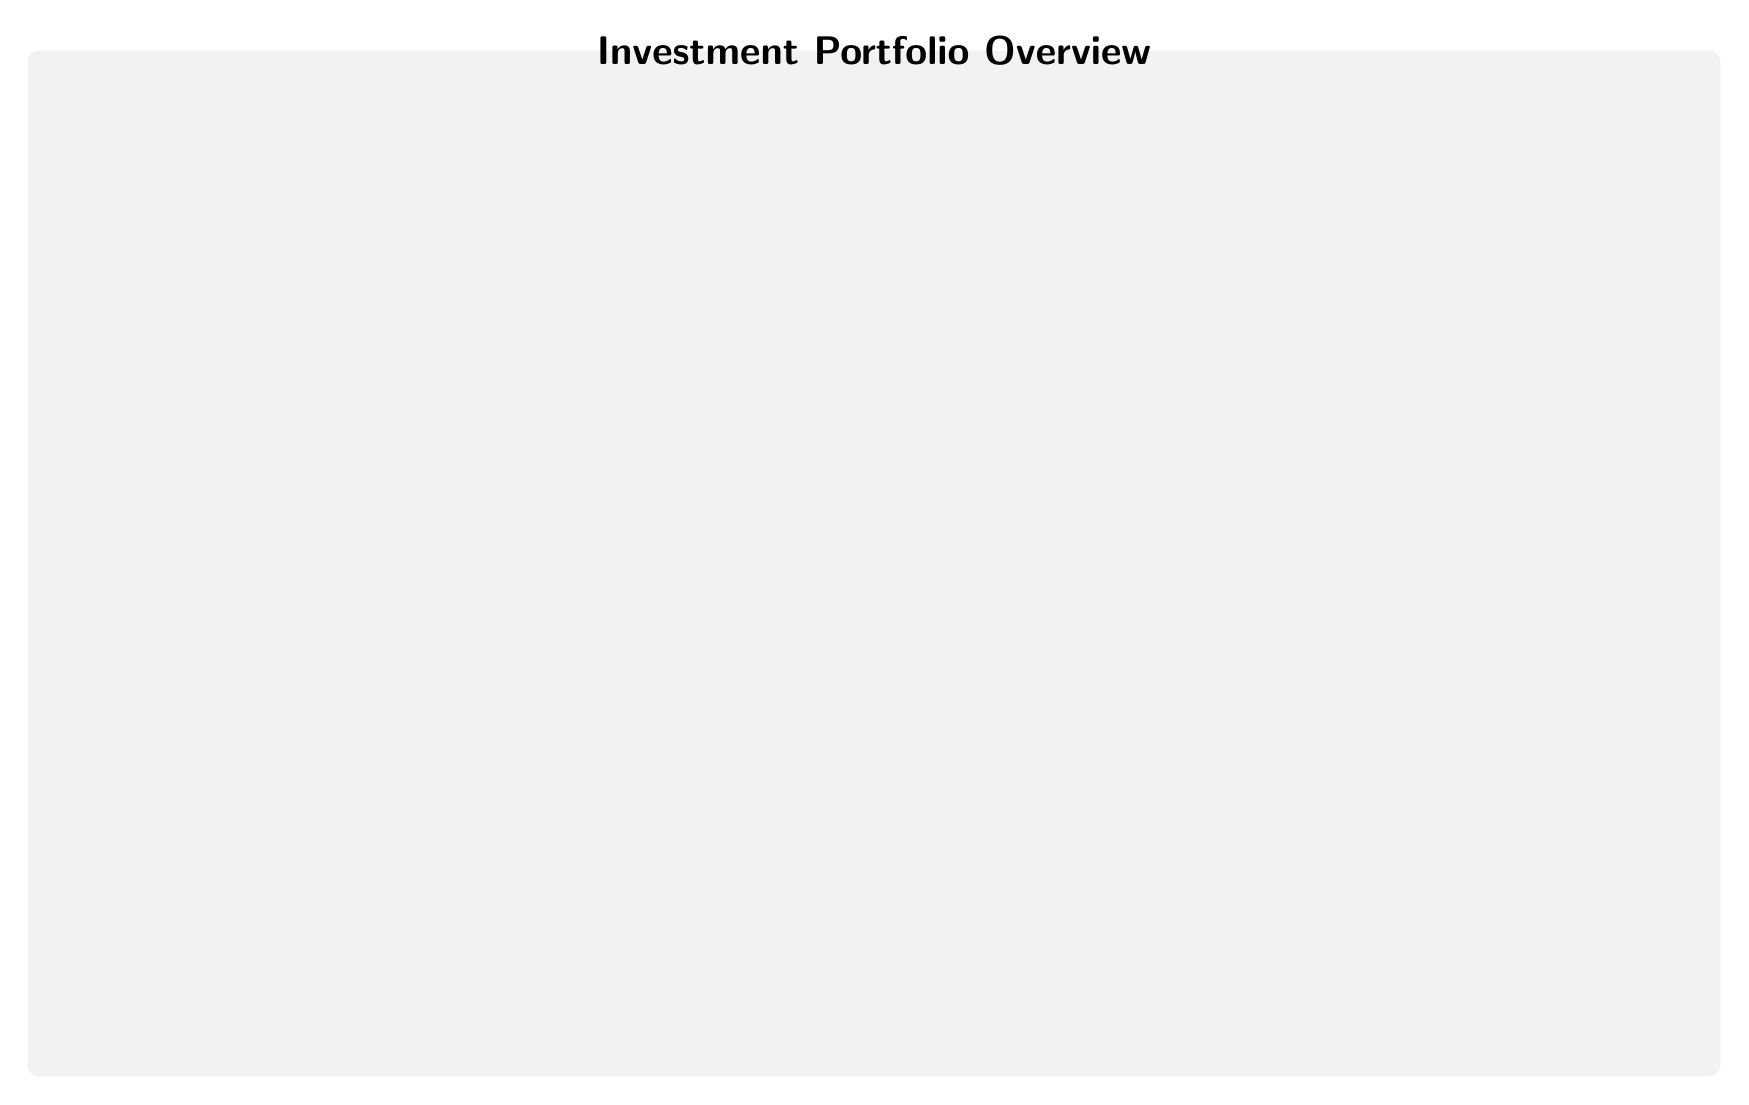What are the four asset types shown in the diagram? The diagram features four asset types: Stocks, Bonds, Real Estate, and Cash Equivalents. These can be found as the individual nodes that represent different investment classes within the portfolio overview.
Answer: Stocks, Bonds, Real Estate, Cash Equivalents What is the risk level associated with stocks? The diagram indicates that the risk level for stocks is categorized as "High." This is stated clearly within the stocks node of the diagram.
Answer: High Which asset type has the lowest risk? According to the diagram, cash equivalents are identified as having the "Low" risk level. This information can be found in the respective cash node.
Answer: Low What is the performance metric used for bonds? The metric listed for bonds in the diagram is "Yield, Duration." These performance metrics are shared within the bonds node and indicate how the bonds are evaluated.
Answer: Yield, Duration What relationship does real estate have with cash equivalents? The diagram shows a directional relationship from real estate to cash equivalents with an edge labeled "Liquidity Management." This implies that real estate investments can help manage liquidity for cash positions.
Answer: Liquidity Management How many nodes are present in the diagram? The diagram contains a total of four asset nodes (Stocks, Bonds, Real Estate, Cash Equivalents), plus one additional node for the title, making it a total of five identified nodes.
Answer: 4 What is the diversification benefit between stocks and bonds? The diagram illustrates an edge labeled "Diversification Benefit" pointing from stocks to bonds. This indicates that investing in stocks can help diversify and reduce risk when combined with bonds.
Answer: Diversification Benefit Which asset type focuses on capital growth? It is indicated in the diagram that stocks are associated with capital growth through the directed edge leading from cash to stocks labeled "Capital Growth." This suggests that stocks are intended for growing capital.
Answer: Stocks What examples are given for real estate investments? The examples listed under the real estate node in the diagram include "Rental Properties, REITs." This provides insight into the types of real estate investments that can be made.
Answer: Rental Properties, REITs 